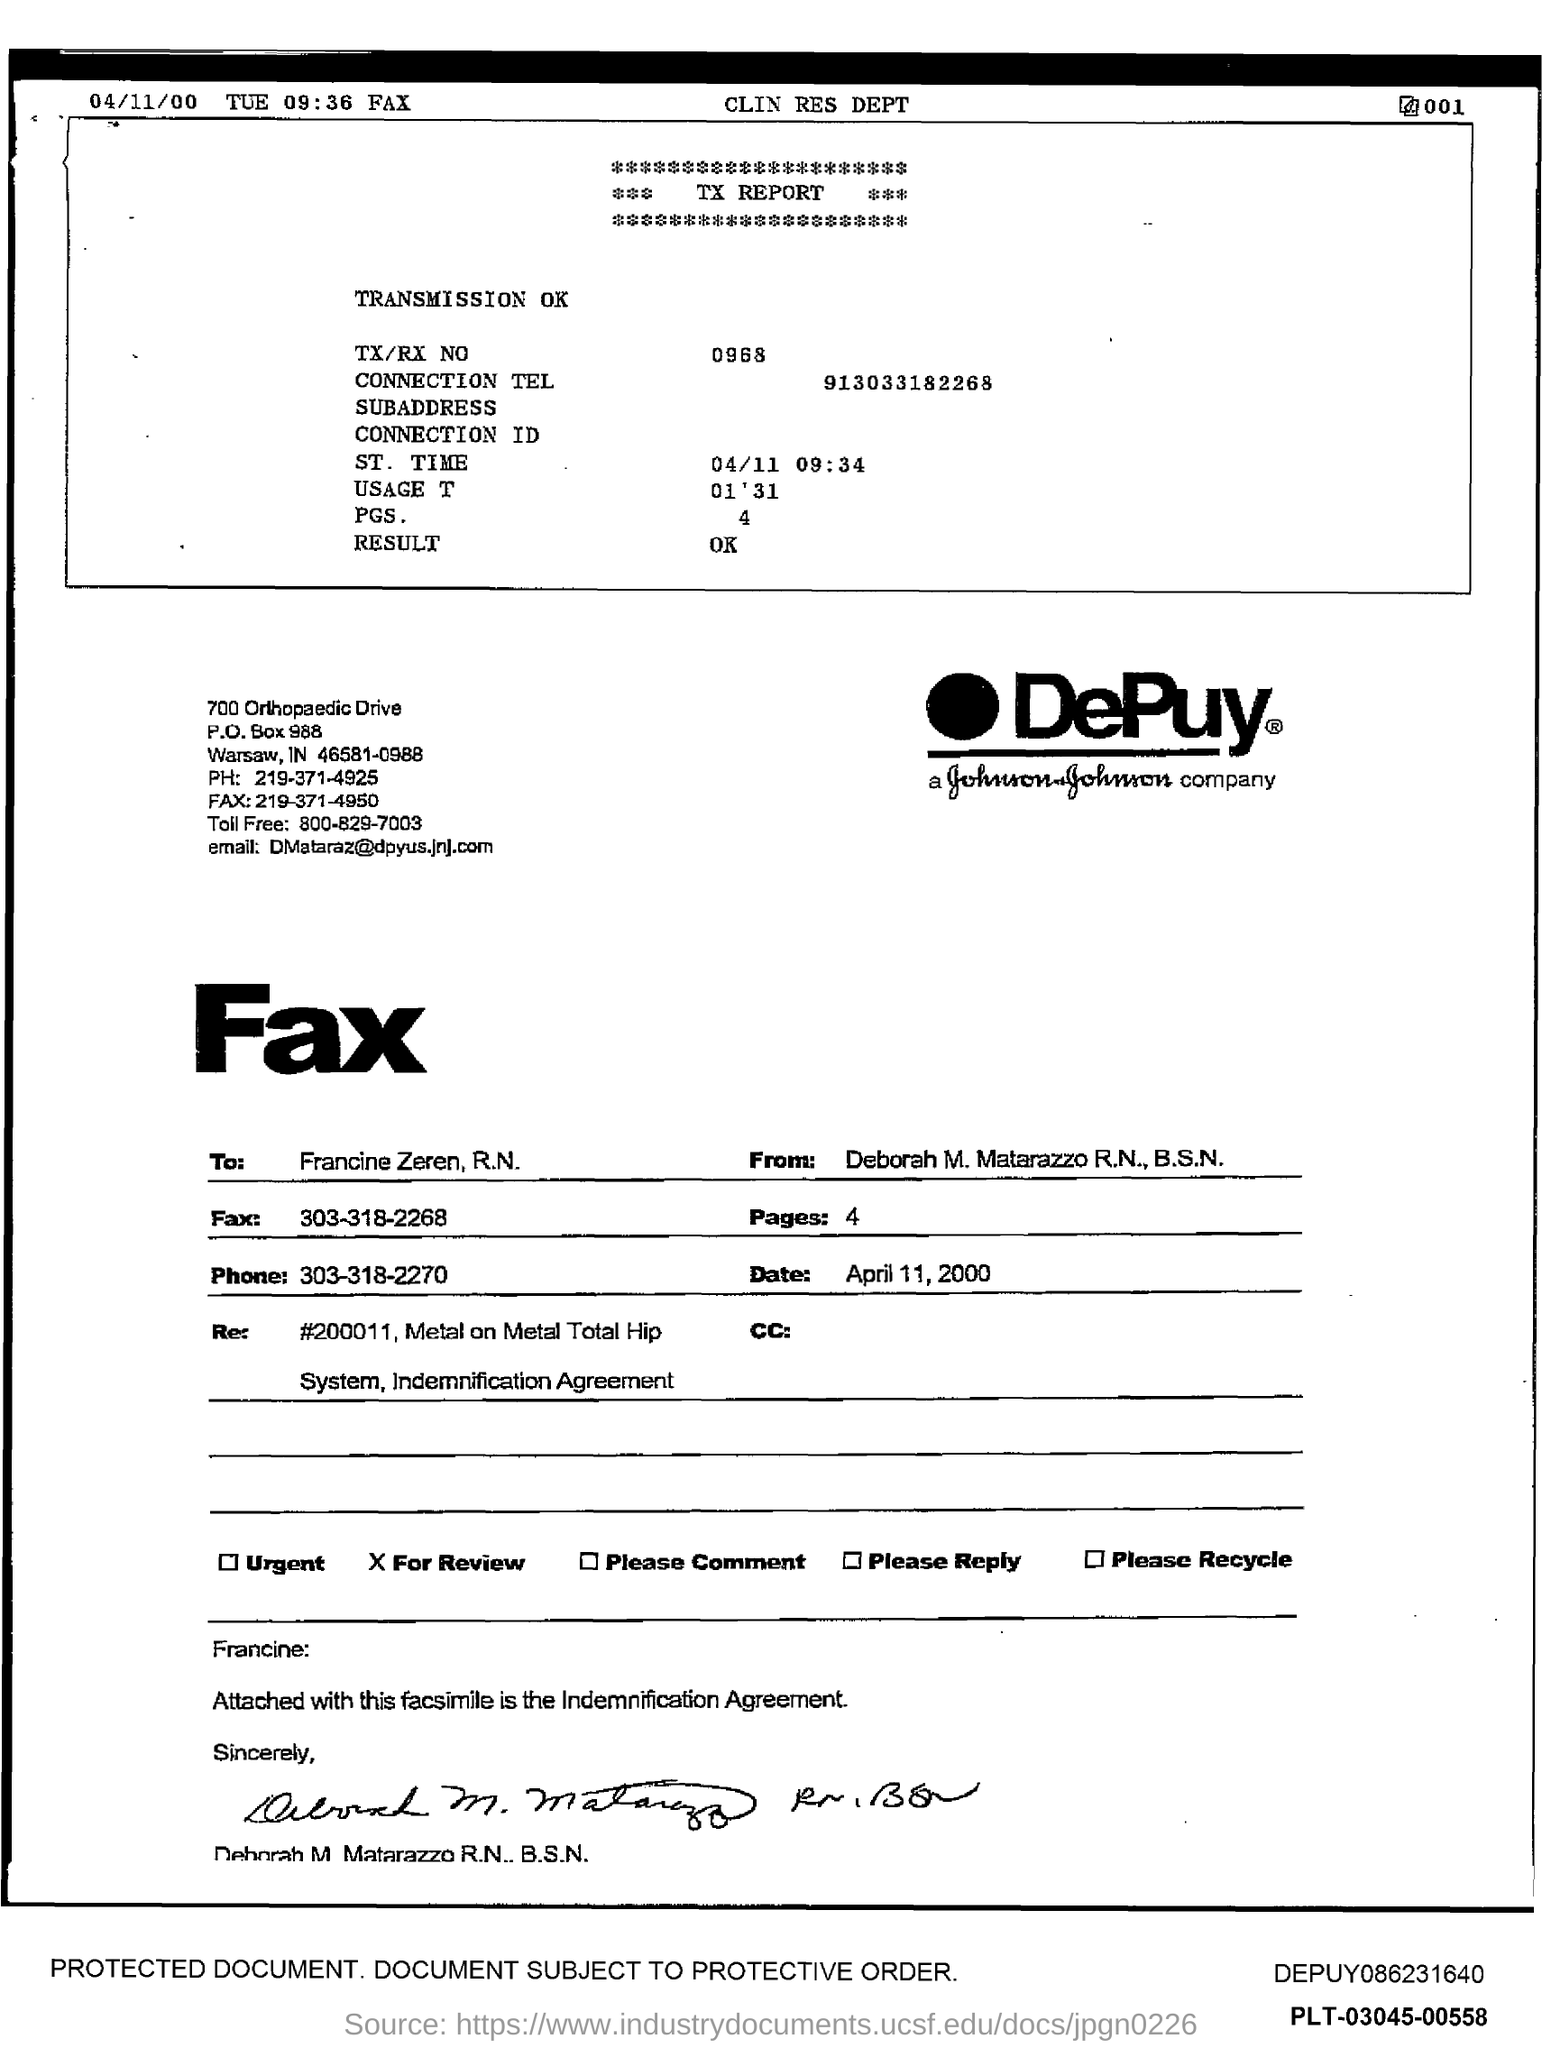Which company logo is seen ?
Your response must be concise. DePuy. Who is the sender of the fax?
Your answer should be compact. Deborah M. Matarazzo R.N., B.S.N. Who is the receiver of the fax?
Make the answer very short. Francine Zeren, R.N. What is the phone no mentioned in the fax?
Provide a short and direct response. 303-318-2270. What is the number of pages in the fax?
Make the answer very short. 4. What is the TX/RX No given in the TX report?
Make the answer very short. 0968. What is the ST. Time mentioned in the TX report?
Give a very brief answer. 04/11 09:34. What is the connection Tel mentioned in the TX Report?
Offer a terse response. 913033182268. What is the Usage Time as per the TX report?
Ensure brevity in your answer.  01'31. 